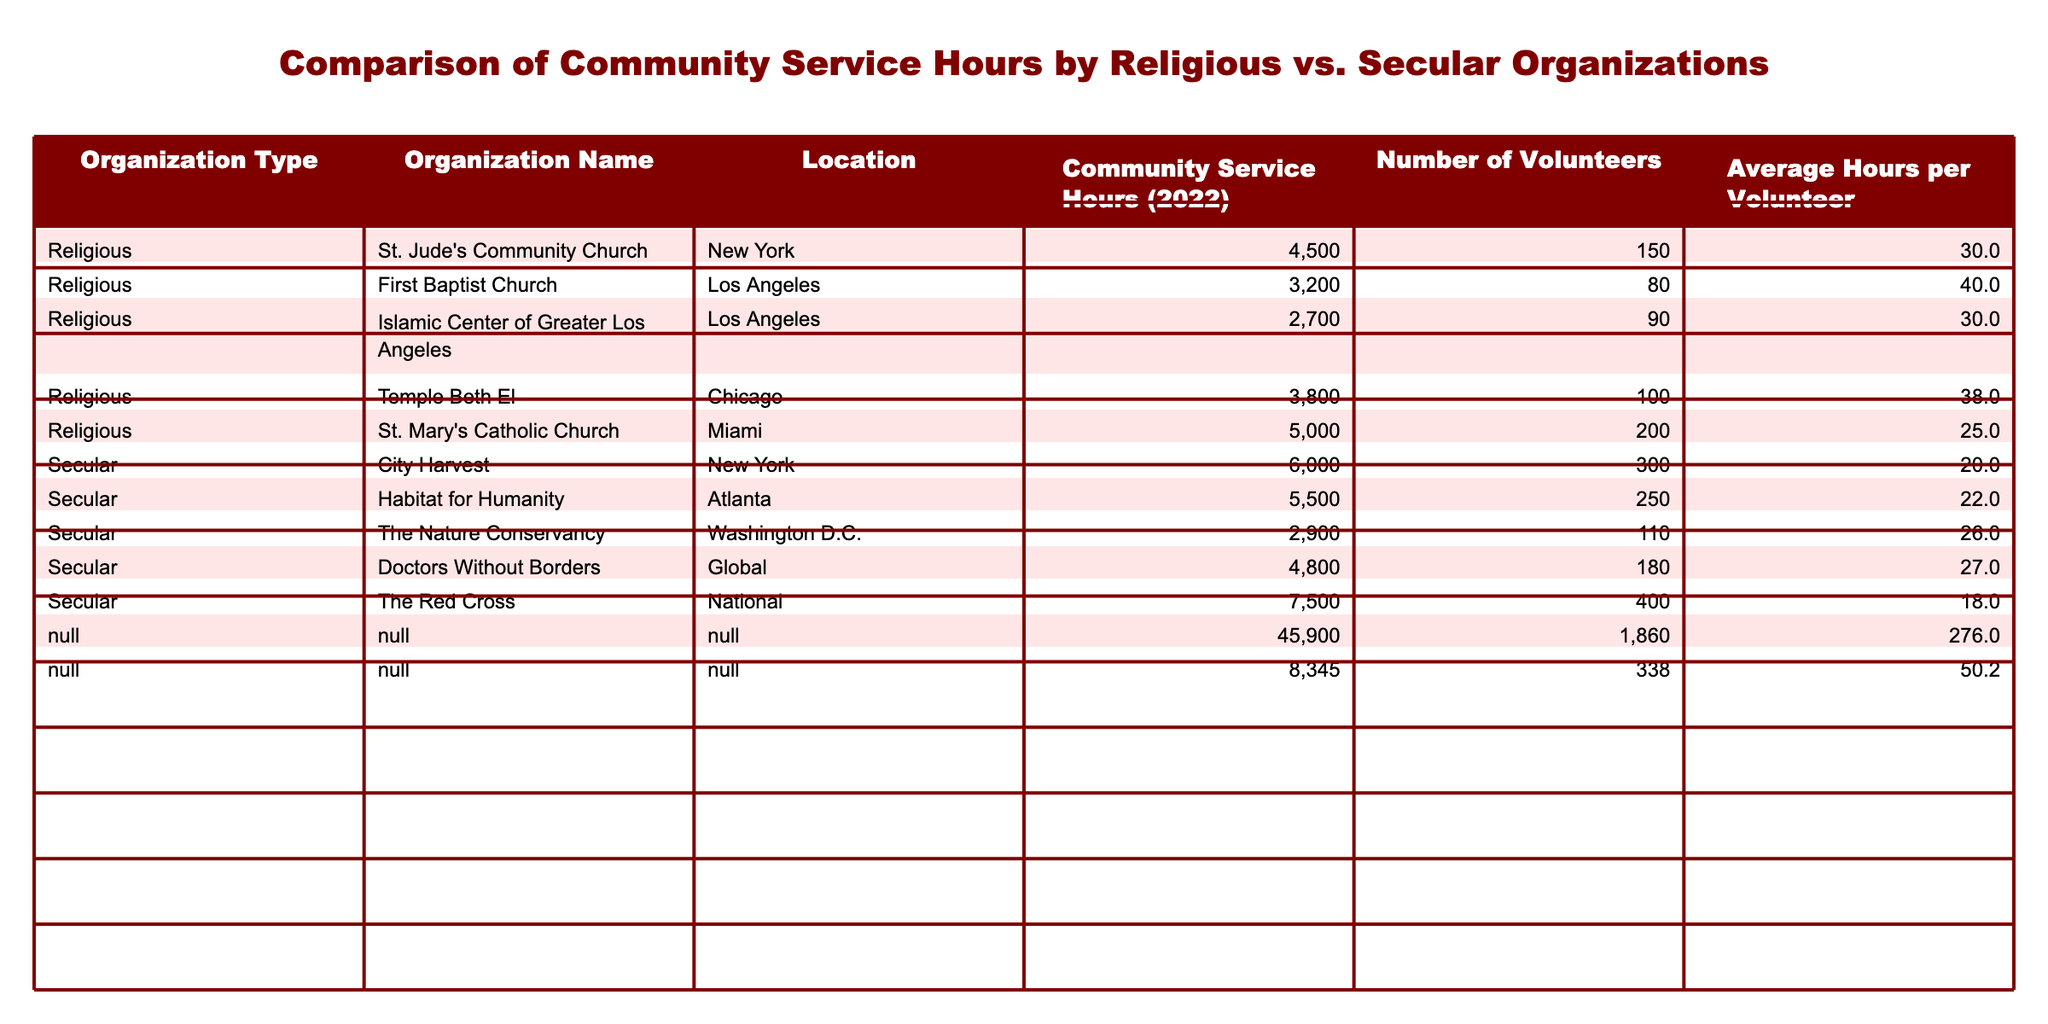What is the total number of community service hours recorded by religious organizations? To find the total, sum the community service hours for all religious organizations: 4500 + 3200 + 2700 + 3800 + 5000 = 19200.
Answer: 19200 Which organization has the highest number of community service hours? Reviewing the community service hours for all organizations, the organization with the highest is The Red Cross with 7500 hours.
Answer: The Red Cross What is the average number of community service hours per volunteer for secular organizations? For secular organizations, we calculate the average by dividing the total community service hours by the total number of volunteers: (6000 + 5500 + 2900 + 4800 + 7500) / (300 + 250 + 110 + 180 + 400) = 4350 / 1240 ≈ 3.51.
Answer: 3.51 Does St. Jude's Community Church have more service hours than City Harvest? Comparing the community service hours, St. Jude's has 4500 hours and City Harvest has 6000 hours, so the statement is false.
Answer: False What is the difference in total community service hours between religious and secular organizations? First, we sum the service hours for religious (19200) and secular (28700) organizations. The difference is 28700 - 19200 = 9500.
Answer: 9500 Which religious organization has the lowest average hours per volunteer? To find this, we compare the average hours per volunteer: St. Jude's (30), First Baptist (40), Islamic Center (30), Temple Beth El (38), St. Mary's (25). St. Mary's has the lowest at 25.
Answer: St. Mary's Catholic Church If we combine the community service hours of the top three secular organizations, what is the total? Adding the hours of the top three secular organizations, The Red Cross (7500), City Harvest (6000), and Habitat for Humanity (5500), gives 7500 + 6000 + 5500 = 19000.
Answer: 19000 What percentage of the total community service hours do religious organizations contribute? First, calculate the total hours: 19200 (religious) + 28700 (secular) = 47900. The percentage for religious is (19200 / 47900) * 100 ≈ 40.12%.
Answer: 40.12% 